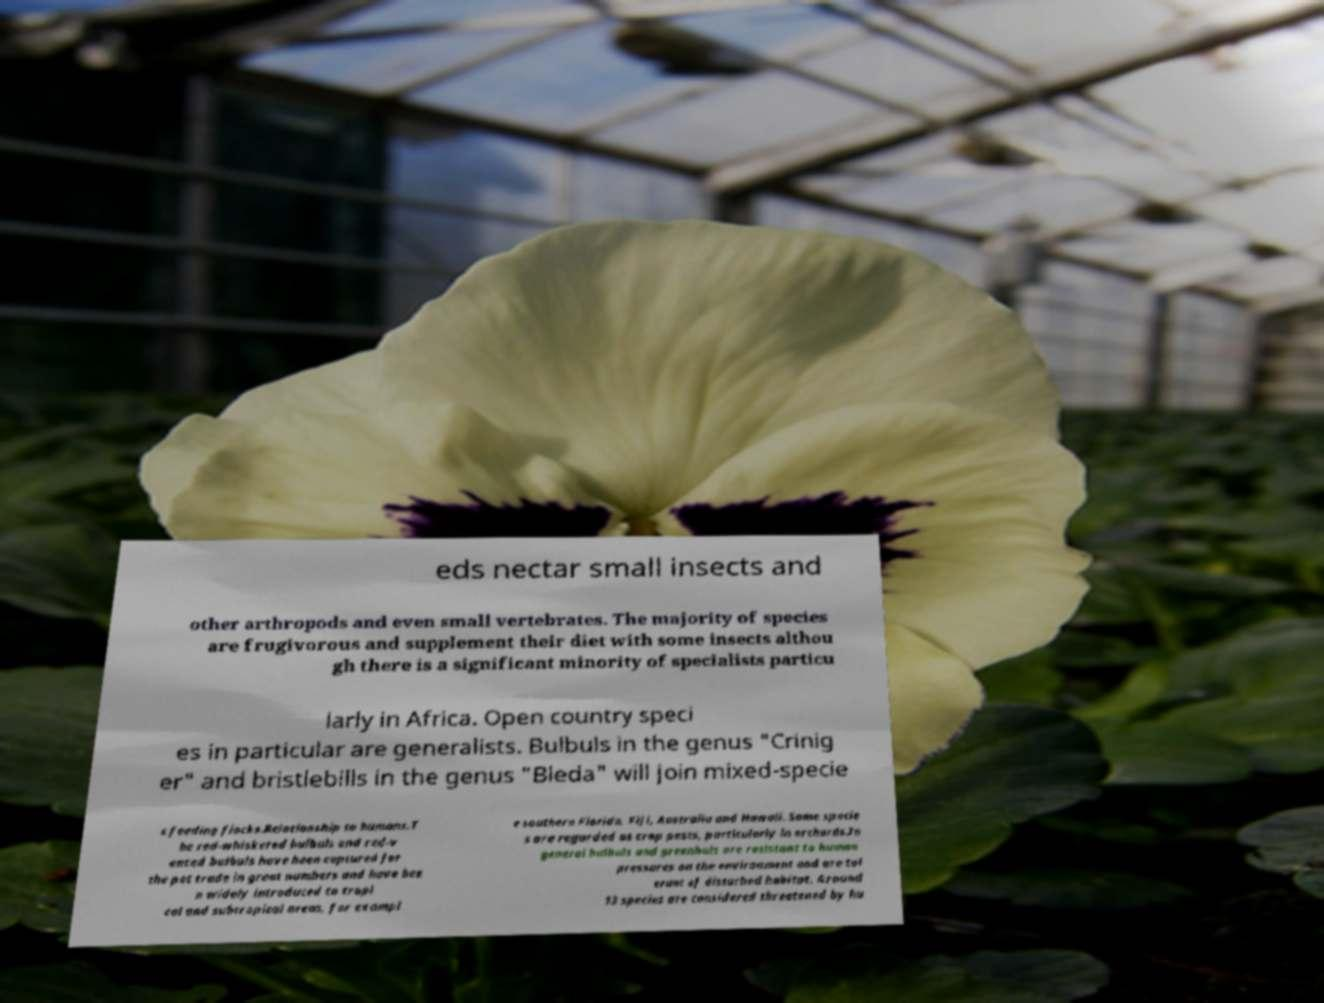For documentation purposes, I need the text within this image transcribed. Could you provide that? eds nectar small insects and other arthropods and even small vertebrates. The majority of species are frugivorous and supplement their diet with some insects althou gh there is a significant minority of specialists particu larly in Africa. Open country speci es in particular are generalists. Bulbuls in the genus "Crinig er" and bristlebills in the genus "Bleda" will join mixed-specie s feeding flocks.Relationship to humans.T he red-whiskered bulbuls and red-v ented bulbuls have been captured for the pet trade in great numbers and have bee n widely introduced to tropi cal and subtropical areas, for exampl e southern Florida, Fiji, Australia and Hawaii. Some specie s are regarded as crop pests, particularly in orchards.In general bulbuls and greenbuls are resistant to human pressures on the environment and are tol erant of disturbed habitat. Around 13 species are considered threatened by hu 